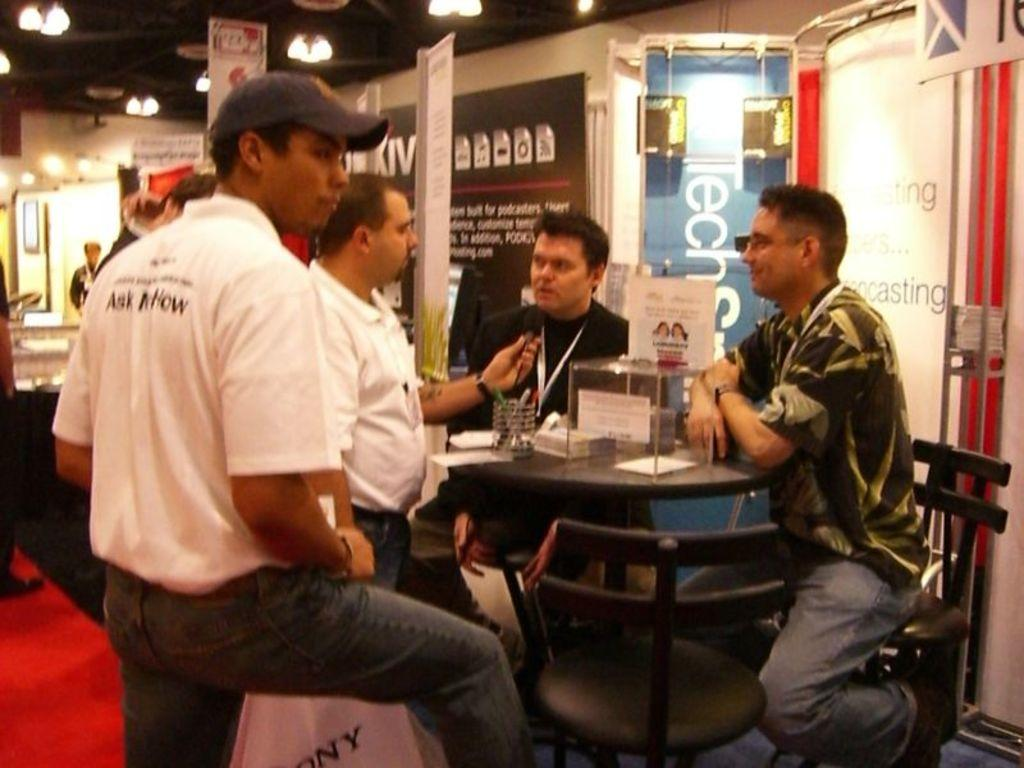What are the people in the image doing? The people in the image are sitting on a table. What can be seen above the people in the image? There are stationary objects above the people. What architectural features are visible in the background of the image? There are doors in the background of the image. What is attached to the doors in the image? Posters are attached to the doors. What is the name of the impulse that causes the people to sit on the table in the image? There is no impulse mentioned in the image, and the people's actions are not attributed to any specific cause. 